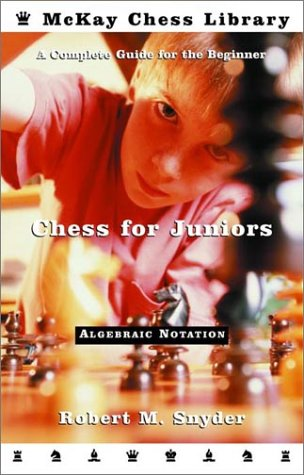What does the use of 'Algebraic Notation' on the cover imply about the book's content? The mention of 'Algebraic Notation' on the cover indicates that the book teaches chess moves and positions using the standardized system of notation, which is essential for recording and studying chess games. 